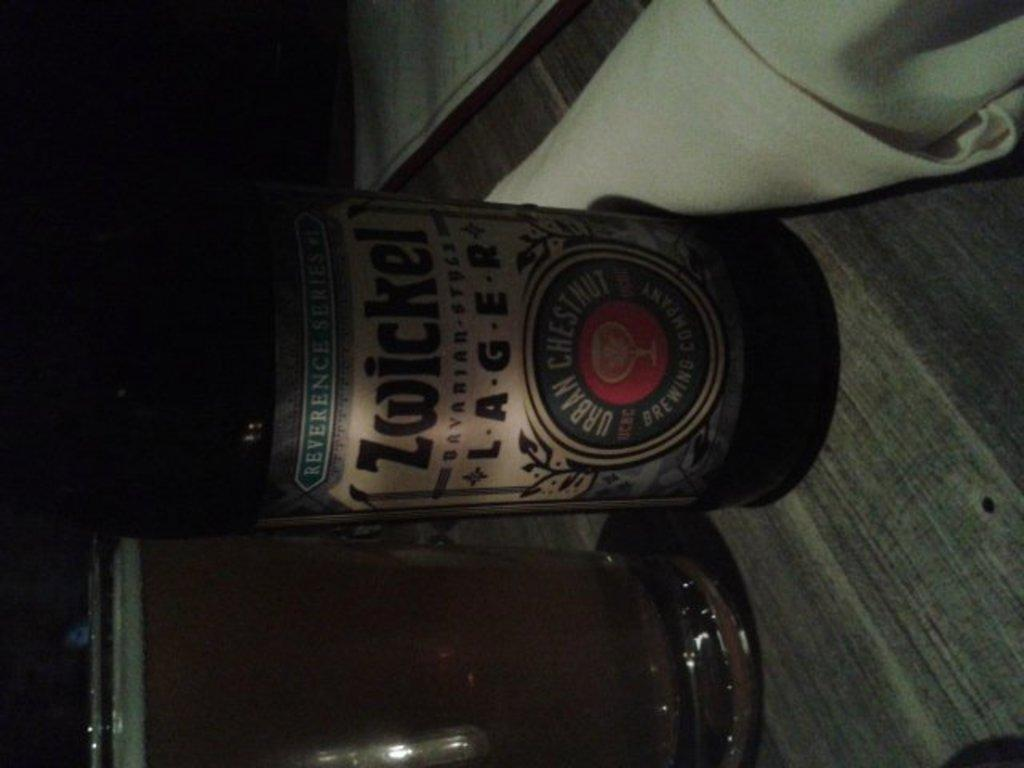Provide a one-sentence caption for the provided image. A bottle of Zwickel lager next to a filled glass. 